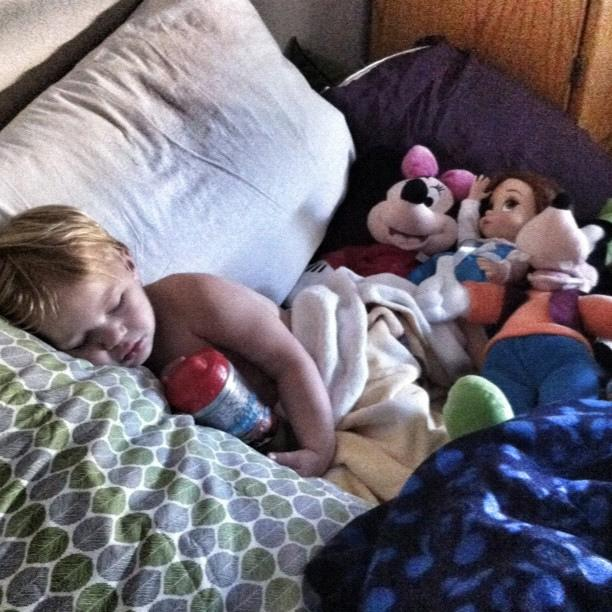In which one of these cities can you meet the characters shown here? Please explain your reasoning. anaheim. Disneyland is in this city 